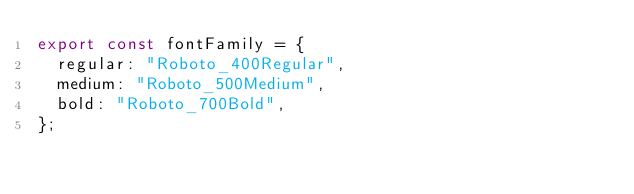Convert code to text. <code><loc_0><loc_0><loc_500><loc_500><_JavaScript_>export const fontFamily = {
  regular: "Roboto_400Regular",
  medium: "Roboto_500Medium",
  bold: "Roboto_700Bold",
};
</code> 